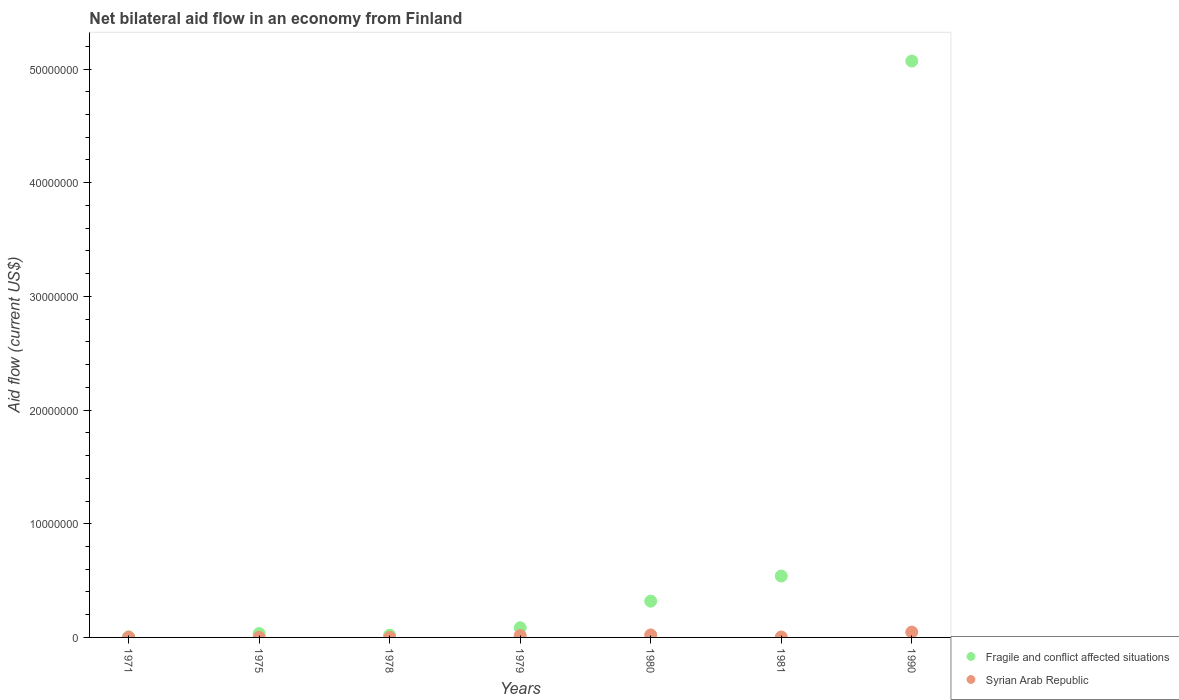What is the net bilateral aid flow in Fragile and conflict affected situations in 1990?
Give a very brief answer. 5.07e+07. Across all years, what is the maximum net bilateral aid flow in Fragile and conflict affected situations?
Keep it short and to the point. 5.07e+07. Across all years, what is the minimum net bilateral aid flow in Syrian Arab Republic?
Your answer should be compact. 10000. In which year was the net bilateral aid flow in Syrian Arab Republic minimum?
Provide a short and direct response. 1975. What is the total net bilateral aid flow in Fragile and conflict affected situations in the graph?
Provide a succinct answer. 6.07e+07. What is the difference between the net bilateral aid flow in Syrian Arab Republic in 1971 and that in 1990?
Give a very brief answer. -4.50e+05. What is the difference between the net bilateral aid flow in Fragile and conflict affected situations in 1981 and the net bilateral aid flow in Syrian Arab Republic in 1990?
Give a very brief answer. 4.93e+06. What is the average net bilateral aid flow in Fragile and conflict affected situations per year?
Make the answer very short. 8.68e+06. Is the difference between the net bilateral aid flow in Fragile and conflict affected situations in 1975 and 1981 greater than the difference between the net bilateral aid flow in Syrian Arab Republic in 1975 and 1981?
Provide a short and direct response. No. What is the difference between the highest and the second highest net bilateral aid flow in Fragile and conflict affected situations?
Keep it short and to the point. 4.53e+07. What is the difference between the highest and the lowest net bilateral aid flow in Syrian Arab Republic?
Give a very brief answer. 4.60e+05. Is the sum of the net bilateral aid flow in Syrian Arab Republic in 1975 and 1980 greater than the maximum net bilateral aid flow in Fragile and conflict affected situations across all years?
Your answer should be compact. No. Is the net bilateral aid flow in Fragile and conflict affected situations strictly greater than the net bilateral aid flow in Syrian Arab Republic over the years?
Your answer should be compact. Yes. What is the difference between two consecutive major ticks on the Y-axis?
Provide a succinct answer. 1.00e+07. Are the values on the major ticks of Y-axis written in scientific E-notation?
Provide a short and direct response. No. Does the graph contain any zero values?
Your answer should be compact. No. Where does the legend appear in the graph?
Your response must be concise. Bottom right. What is the title of the graph?
Provide a short and direct response. Net bilateral aid flow in an economy from Finland. Does "Switzerland" appear as one of the legend labels in the graph?
Your answer should be very brief. No. What is the label or title of the Y-axis?
Provide a short and direct response. Aid flow (current US$). What is the Aid flow (current US$) in Fragile and conflict affected situations in 1971?
Offer a very short reply. 5.00e+04. What is the Aid flow (current US$) of Syrian Arab Republic in 1975?
Make the answer very short. 10000. What is the Aid flow (current US$) of Fragile and conflict affected situations in 1978?
Make the answer very short. 2.00e+05. What is the Aid flow (current US$) of Fragile and conflict affected situations in 1979?
Your answer should be very brief. 8.50e+05. What is the Aid flow (current US$) of Syrian Arab Republic in 1979?
Provide a succinct answer. 1.60e+05. What is the Aid flow (current US$) of Fragile and conflict affected situations in 1980?
Provide a succinct answer. 3.19e+06. What is the Aid flow (current US$) of Syrian Arab Republic in 1980?
Keep it short and to the point. 2.20e+05. What is the Aid flow (current US$) of Fragile and conflict affected situations in 1981?
Make the answer very short. 5.40e+06. What is the Aid flow (current US$) in Fragile and conflict affected situations in 1990?
Provide a short and direct response. 5.07e+07. What is the Aid flow (current US$) in Syrian Arab Republic in 1990?
Your answer should be very brief. 4.70e+05. Across all years, what is the maximum Aid flow (current US$) in Fragile and conflict affected situations?
Offer a very short reply. 5.07e+07. What is the total Aid flow (current US$) in Fragile and conflict affected situations in the graph?
Your answer should be compact. 6.07e+07. What is the total Aid flow (current US$) of Syrian Arab Republic in the graph?
Offer a very short reply. 9.30e+05. What is the difference between the Aid flow (current US$) of Fragile and conflict affected situations in 1971 and that in 1975?
Your answer should be very brief. -2.90e+05. What is the difference between the Aid flow (current US$) in Fragile and conflict affected situations in 1971 and that in 1978?
Provide a short and direct response. -1.50e+05. What is the difference between the Aid flow (current US$) in Syrian Arab Republic in 1971 and that in 1978?
Your answer should be compact. 10000. What is the difference between the Aid flow (current US$) in Fragile and conflict affected situations in 1971 and that in 1979?
Give a very brief answer. -8.00e+05. What is the difference between the Aid flow (current US$) of Fragile and conflict affected situations in 1971 and that in 1980?
Give a very brief answer. -3.14e+06. What is the difference between the Aid flow (current US$) of Syrian Arab Republic in 1971 and that in 1980?
Provide a succinct answer. -2.00e+05. What is the difference between the Aid flow (current US$) of Fragile and conflict affected situations in 1971 and that in 1981?
Keep it short and to the point. -5.35e+06. What is the difference between the Aid flow (current US$) of Fragile and conflict affected situations in 1971 and that in 1990?
Provide a short and direct response. -5.06e+07. What is the difference between the Aid flow (current US$) of Syrian Arab Republic in 1971 and that in 1990?
Ensure brevity in your answer.  -4.50e+05. What is the difference between the Aid flow (current US$) of Syrian Arab Republic in 1975 and that in 1978?
Your response must be concise. 0. What is the difference between the Aid flow (current US$) in Fragile and conflict affected situations in 1975 and that in 1979?
Give a very brief answer. -5.10e+05. What is the difference between the Aid flow (current US$) in Fragile and conflict affected situations in 1975 and that in 1980?
Offer a very short reply. -2.85e+06. What is the difference between the Aid flow (current US$) of Syrian Arab Republic in 1975 and that in 1980?
Provide a succinct answer. -2.10e+05. What is the difference between the Aid flow (current US$) of Fragile and conflict affected situations in 1975 and that in 1981?
Make the answer very short. -5.06e+06. What is the difference between the Aid flow (current US$) of Fragile and conflict affected situations in 1975 and that in 1990?
Your response must be concise. -5.04e+07. What is the difference between the Aid flow (current US$) of Syrian Arab Republic in 1975 and that in 1990?
Give a very brief answer. -4.60e+05. What is the difference between the Aid flow (current US$) in Fragile and conflict affected situations in 1978 and that in 1979?
Your answer should be very brief. -6.50e+05. What is the difference between the Aid flow (current US$) of Fragile and conflict affected situations in 1978 and that in 1980?
Offer a terse response. -2.99e+06. What is the difference between the Aid flow (current US$) in Syrian Arab Republic in 1978 and that in 1980?
Make the answer very short. -2.10e+05. What is the difference between the Aid flow (current US$) of Fragile and conflict affected situations in 1978 and that in 1981?
Make the answer very short. -5.20e+06. What is the difference between the Aid flow (current US$) in Syrian Arab Republic in 1978 and that in 1981?
Provide a short and direct response. -3.00e+04. What is the difference between the Aid flow (current US$) in Fragile and conflict affected situations in 1978 and that in 1990?
Your answer should be very brief. -5.05e+07. What is the difference between the Aid flow (current US$) in Syrian Arab Republic in 1978 and that in 1990?
Provide a short and direct response. -4.60e+05. What is the difference between the Aid flow (current US$) in Fragile and conflict affected situations in 1979 and that in 1980?
Provide a short and direct response. -2.34e+06. What is the difference between the Aid flow (current US$) in Fragile and conflict affected situations in 1979 and that in 1981?
Keep it short and to the point. -4.55e+06. What is the difference between the Aid flow (current US$) of Syrian Arab Republic in 1979 and that in 1981?
Provide a succinct answer. 1.20e+05. What is the difference between the Aid flow (current US$) of Fragile and conflict affected situations in 1979 and that in 1990?
Offer a very short reply. -4.98e+07. What is the difference between the Aid flow (current US$) in Syrian Arab Republic in 1979 and that in 1990?
Provide a short and direct response. -3.10e+05. What is the difference between the Aid flow (current US$) of Fragile and conflict affected situations in 1980 and that in 1981?
Provide a short and direct response. -2.21e+06. What is the difference between the Aid flow (current US$) of Syrian Arab Republic in 1980 and that in 1981?
Ensure brevity in your answer.  1.80e+05. What is the difference between the Aid flow (current US$) of Fragile and conflict affected situations in 1980 and that in 1990?
Make the answer very short. -4.75e+07. What is the difference between the Aid flow (current US$) in Fragile and conflict affected situations in 1981 and that in 1990?
Your response must be concise. -4.53e+07. What is the difference between the Aid flow (current US$) of Syrian Arab Republic in 1981 and that in 1990?
Give a very brief answer. -4.30e+05. What is the difference between the Aid flow (current US$) of Fragile and conflict affected situations in 1971 and the Aid flow (current US$) of Syrian Arab Republic in 1975?
Your answer should be compact. 4.00e+04. What is the difference between the Aid flow (current US$) of Fragile and conflict affected situations in 1971 and the Aid flow (current US$) of Syrian Arab Republic in 1978?
Offer a terse response. 4.00e+04. What is the difference between the Aid flow (current US$) in Fragile and conflict affected situations in 1971 and the Aid flow (current US$) in Syrian Arab Republic in 1990?
Offer a terse response. -4.20e+05. What is the difference between the Aid flow (current US$) of Fragile and conflict affected situations in 1975 and the Aid flow (current US$) of Syrian Arab Republic in 1978?
Your response must be concise. 3.30e+05. What is the difference between the Aid flow (current US$) in Fragile and conflict affected situations in 1975 and the Aid flow (current US$) in Syrian Arab Republic in 1981?
Make the answer very short. 3.00e+05. What is the difference between the Aid flow (current US$) of Fragile and conflict affected situations in 1975 and the Aid flow (current US$) of Syrian Arab Republic in 1990?
Your answer should be compact. -1.30e+05. What is the difference between the Aid flow (current US$) of Fragile and conflict affected situations in 1978 and the Aid flow (current US$) of Syrian Arab Republic in 1979?
Your response must be concise. 4.00e+04. What is the difference between the Aid flow (current US$) of Fragile and conflict affected situations in 1978 and the Aid flow (current US$) of Syrian Arab Republic in 1980?
Keep it short and to the point. -2.00e+04. What is the difference between the Aid flow (current US$) of Fragile and conflict affected situations in 1978 and the Aid flow (current US$) of Syrian Arab Republic in 1981?
Ensure brevity in your answer.  1.60e+05. What is the difference between the Aid flow (current US$) of Fragile and conflict affected situations in 1978 and the Aid flow (current US$) of Syrian Arab Republic in 1990?
Keep it short and to the point. -2.70e+05. What is the difference between the Aid flow (current US$) in Fragile and conflict affected situations in 1979 and the Aid flow (current US$) in Syrian Arab Republic in 1980?
Ensure brevity in your answer.  6.30e+05. What is the difference between the Aid flow (current US$) of Fragile and conflict affected situations in 1979 and the Aid flow (current US$) of Syrian Arab Republic in 1981?
Make the answer very short. 8.10e+05. What is the difference between the Aid flow (current US$) in Fragile and conflict affected situations in 1979 and the Aid flow (current US$) in Syrian Arab Republic in 1990?
Keep it short and to the point. 3.80e+05. What is the difference between the Aid flow (current US$) in Fragile and conflict affected situations in 1980 and the Aid flow (current US$) in Syrian Arab Republic in 1981?
Provide a succinct answer. 3.15e+06. What is the difference between the Aid flow (current US$) in Fragile and conflict affected situations in 1980 and the Aid flow (current US$) in Syrian Arab Republic in 1990?
Your answer should be very brief. 2.72e+06. What is the difference between the Aid flow (current US$) of Fragile and conflict affected situations in 1981 and the Aid flow (current US$) of Syrian Arab Republic in 1990?
Your response must be concise. 4.93e+06. What is the average Aid flow (current US$) of Fragile and conflict affected situations per year?
Your answer should be compact. 8.68e+06. What is the average Aid flow (current US$) of Syrian Arab Republic per year?
Offer a very short reply. 1.33e+05. In the year 1979, what is the difference between the Aid flow (current US$) of Fragile and conflict affected situations and Aid flow (current US$) of Syrian Arab Republic?
Your response must be concise. 6.90e+05. In the year 1980, what is the difference between the Aid flow (current US$) in Fragile and conflict affected situations and Aid flow (current US$) in Syrian Arab Republic?
Offer a terse response. 2.97e+06. In the year 1981, what is the difference between the Aid flow (current US$) of Fragile and conflict affected situations and Aid flow (current US$) of Syrian Arab Republic?
Your answer should be compact. 5.36e+06. In the year 1990, what is the difference between the Aid flow (current US$) in Fragile and conflict affected situations and Aid flow (current US$) in Syrian Arab Republic?
Offer a very short reply. 5.02e+07. What is the ratio of the Aid flow (current US$) of Fragile and conflict affected situations in 1971 to that in 1975?
Offer a very short reply. 0.15. What is the ratio of the Aid flow (current US$) in Fragile and conflict affected situations in 1971 to that in 1979?
Your answer should be compact. 0.06. What is the ratio of the Aid flow (current US$) in Syrian Arab Republic in 1971 to that in 1979?
Provide a succinct answer. 0.12. What is the ratio of the Aid flow (current US$) in Fragile and conflict affected situations in 1971 to that in 1980?
Keep it short and to the point. 0.02. What is the ratio of the Aid flow (current US$) of Syrian Arab Republic in 1971 to that in 1980?
Your response must be concise. 0.09. What is the ratio of the Aid flow (current US$) in Fragile and conflict affected situations in 1971 to that in 1981?
Provide a short and direct response. 0.01. What is the ratio of the Aid flow (current US$) in Syrian Arab Republic in 1971 to that in 1990?
Offer a terse response. 0.04. What is the ratio of the Aid flow (current US$) of Syrian Arab Republic in 1975 to that in 1979?
Your answer should be very brief. 0.06. What is the ratio of the Aid flow (current US$) in Fragile and conflict affected situations in 1975 to that in 1980?
Your response must be concise. 0.11. What is the ratio of the Aid flow (current US$) of Syrian Arab Republic in 1975 to that in 1980?
Keep it short and to the point. 0.05. What is the ratio of the Aid flow (current US$) of Fragile and conflict affected situations in 1975 to that in 1981?
Ensure brevity in your answer.  0.06. What is the ratio of the Aid flow (current US$) in Fragile and conflict affected situations in 1975 to that in 1990?
Keep it short and to the point. 0.01. What is the ratio of the Aid flow (current US$) in Syrian Arab Republic in 1975 to that in 1990?
Your response must be concise. 0.02. What is the ratio of the Aid flow (current US$) of Fragile and conflict affected situations in 1978 to that in 1979?
Make the answer very short. 0.24. What is the ratio of the Aid flow (current US$) in Syrian Arab Republic in 1978 to that in 1979?
Your answer should be very brief. 0.06. What is the ratio of the Aid flow (current US$) of Fragile and conflict affected situations in 1978 to that in 1980?
Your answer should be very brief. 0.06. What is the ratio of the Aid flow (current US$) of Syrian Arab Republic in 1978 to that in 1980?
Keep it short and to the point. 0.05. What is the ratio of the Aid flow (current US$) in Fragile and conflict affected situations in 1978 to that in 1981?
Ensure brevity in your answer.  0.04. What is the ratio of the Aid flow (current US$) in Syrian Arab Republic in 1978 to that in 1981?
Give a very brief answer. 0.25. What is the ratio of the Aid flow (current US$) in Fragile and conflict affected situations in 1978 to that in 1990?
Provide a short and direct response. 0. What is the ratio of the Aid flow (current US$) in Syrian Arab Republic in 1978 to that in 1990?
Give a very brief answer. 0.02. What is the ratio of the Aid flow (current US$) in Fragile and conflict affected situations in 1979 to that in 1980?
Keep it short and to the point. 0.27. What is the ratio of the Aid flow (current US$) in Syrian Arab Republic in 1979 to that in 1980?
Provide a succinct answer. 0.73. What is the ratio of the Aid flow (current US$) in Fragile and conflict affected situations in 1979 to that in 1981?
Provide a succinct answer. 0.16. What is the ratio of the Aid flow (current US$) of Syrian Arab Republic in 1979 to that in 1981?
Offer a terse response. 4. What is the ratio of the Aid flow (current US$) of Fragile and conflict affected situations in 1979 to that in 1990?
Your response must be concise. 0.02. What is the ratio of the Aid flow (current US$) in Syrian Arab Republic in 1979 to that in 1990?
Offer a very short reply. 0.34. What is the ratio of the Aid flow (current US$) of Fragile and conflict affected situations in 1980 to that in 1981?
Ensure brevity in your answer.  0.59. What is the ratio of the Aid flow (current US$) of Syrian Arab Republic in 1980 to that in 1981?
Your answer should be very brief. 5.5. What is the ratio of the Aid flow (current US$) of Fragile and conflict affected situations in 1980 to that in 1990?
Provide a succinct answer. 0.06. What is the ratio of the Aid flow (current US$) in Syrian Arab Republic in 1980 to that in 1990?
Offer a terse response. 0.47. What is the ratio of the Aid flow (current US$) in Fragile and conflict affected situations in 1981 to that in 1990?
Offer a very short reply. 0.11. What is the ratio of the Aid flow (current US$) of Syrian Arab Republic in 1981 to that in 1990?
Offer a very short reply. 0.09. What is the difference between the highest and the second highest Aid flow (current US$) in Fragile and conflict affected situations?
Give a very brief answer. 4.53e+07. What is the difference between the highest and the lowest Aid flow (current US$) of Fragile and conflict affected situations?
Offer a very short reply. 5.06e+07. What is the difference between the highest and the lowest Aid flow (current US$) in Syrian Arab Republic?
Provide a short and direct response. 4.60e+05. 